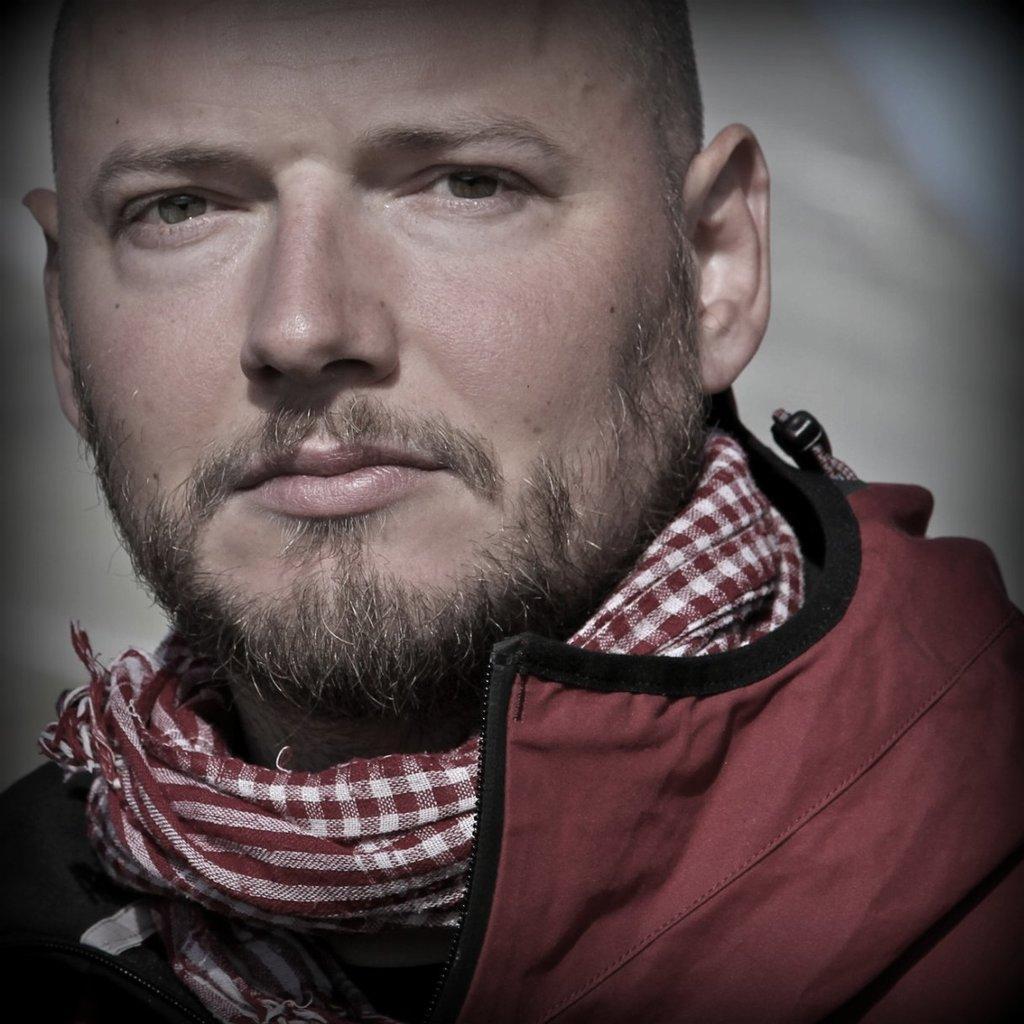Can you describe this image briefly? In this image I can see a man and I can see he is wearing red colour dress. I can also see a cloth around his neck and I can see this image is blurry in the background. 